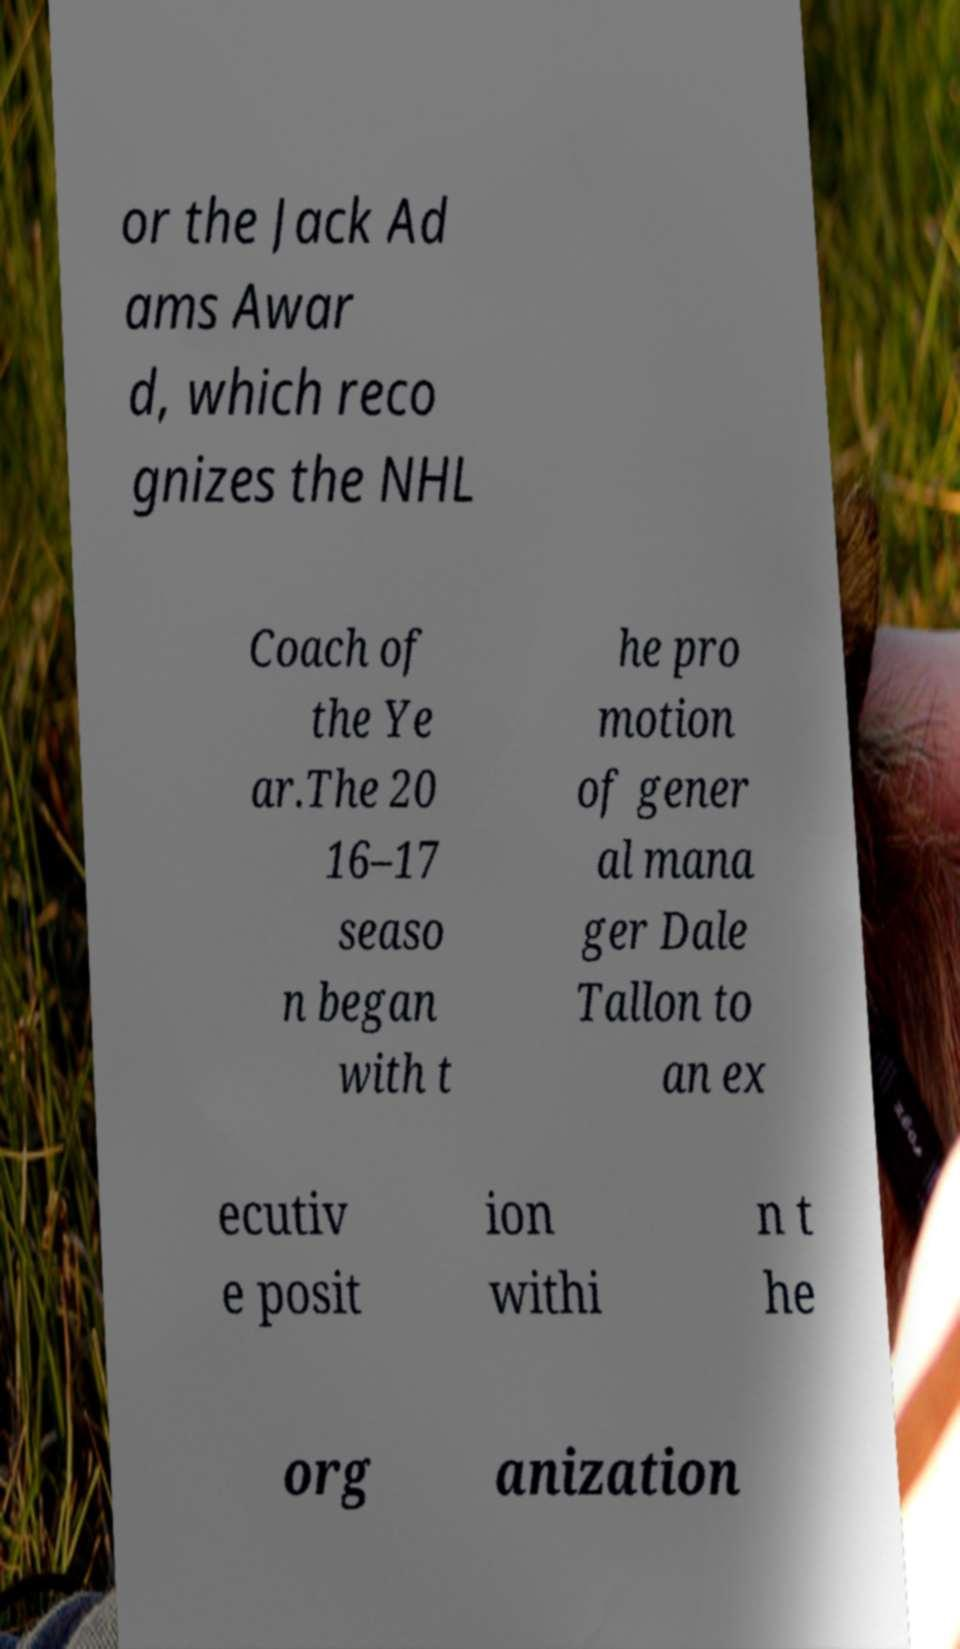Please identify and transcribe the text found in this image. or the Jack Ad ams Awar d, which reco gnizes the NHL Coach of the Ye ar.The 20 16–17 seaso n began with t he pro motion of gener al mana ger Dale Tallon to an ex ecutiv e posit ion withi n t he org anization 